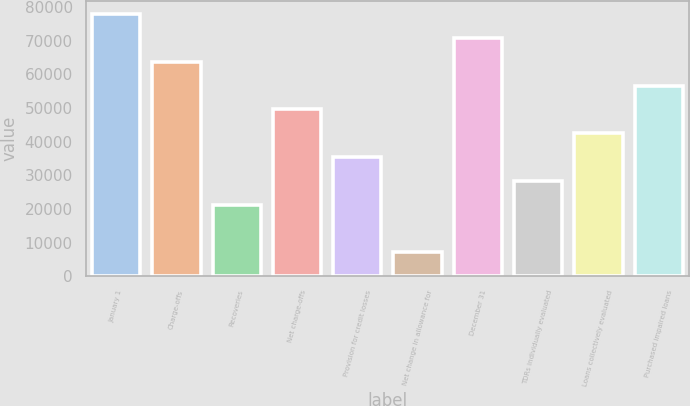Convert chart. <chart><loc_0><loc_0><loc_500><loc_500><bar_chart><fcel>January 1<fcel>Charge-offs<fcel>Recoveries<fcel>Net charge-offs<fcel>Provision for credit losses<fcel>Net change in allowance for<fcel>December 31<fcel>TDRs individually evaluated<fcel>Loans collectively evaluated<fcel>Purchased impaired loans<nl><fcel>77961.2<fcel>63786.9<fcel>21264<fcel>49612.6<fcel>35438.3<fcel>7089.77<fcel>70874<fcel>28351.2<fcel>42525.5<fcel>56699.8<nl></chart> 